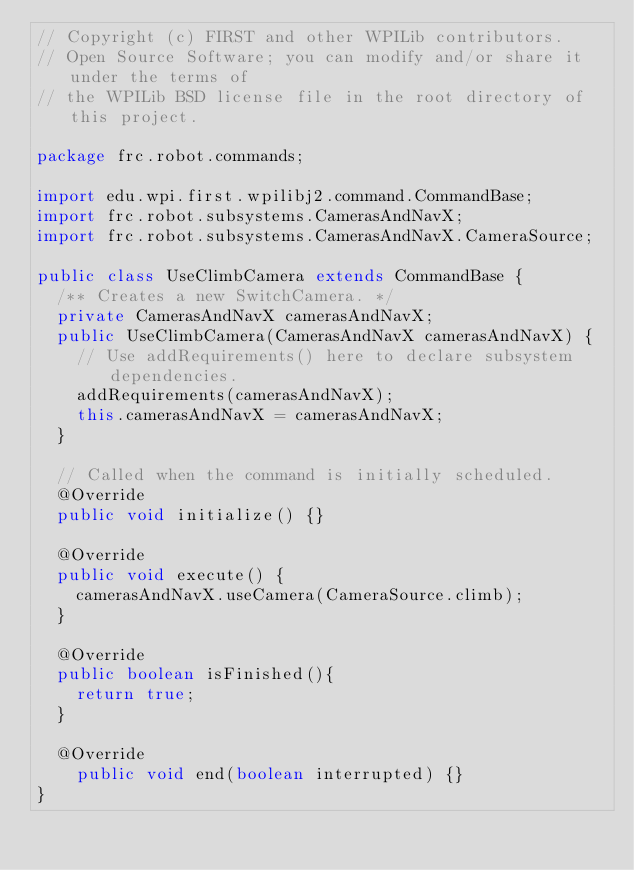<code> <loc_0><loc_0><loc_500><loc_500><_Java_>// Copyright (c) FIRST and other WPILib contributors.
// Open Source Software; you can modify and/or share it under the terms of
// the WPILib BSD license file in the root directory of this project.

package frc.robot.commands;

import edu.wpi.first.wpilibj2.command.CommandBase;
import frc.robot.subsystems.CamerasAndNavX;
import frc.robot.subsystems.CamerasAndNavX.CameraSource;

public class UseClimbCamera extends CommandBase {
  /** Creates a new SwitchCamera. */
  private CamerasAndNavX camerasAndNavX;
  public UseClimbCamera(CamerasAndNavX camerasAndNavX) {
    // Use addRequirements() here to declare subsystem dependencies.
    addRequirements(camerasAndNavX);
    this.camerasAndNavX = camerasAndNavX;
  }

  // Called when the command is initially scheduled.
  @Override
  public void initialize() {}

  @Override
  public void execute() {
    camerasAndNavX.useCamera(CameraSource.climb);
  }

  @Override
  public boolean isFinished(){
    return true;
  }

  @Override
    public void end(boolean interrupted) {}
}</code> 